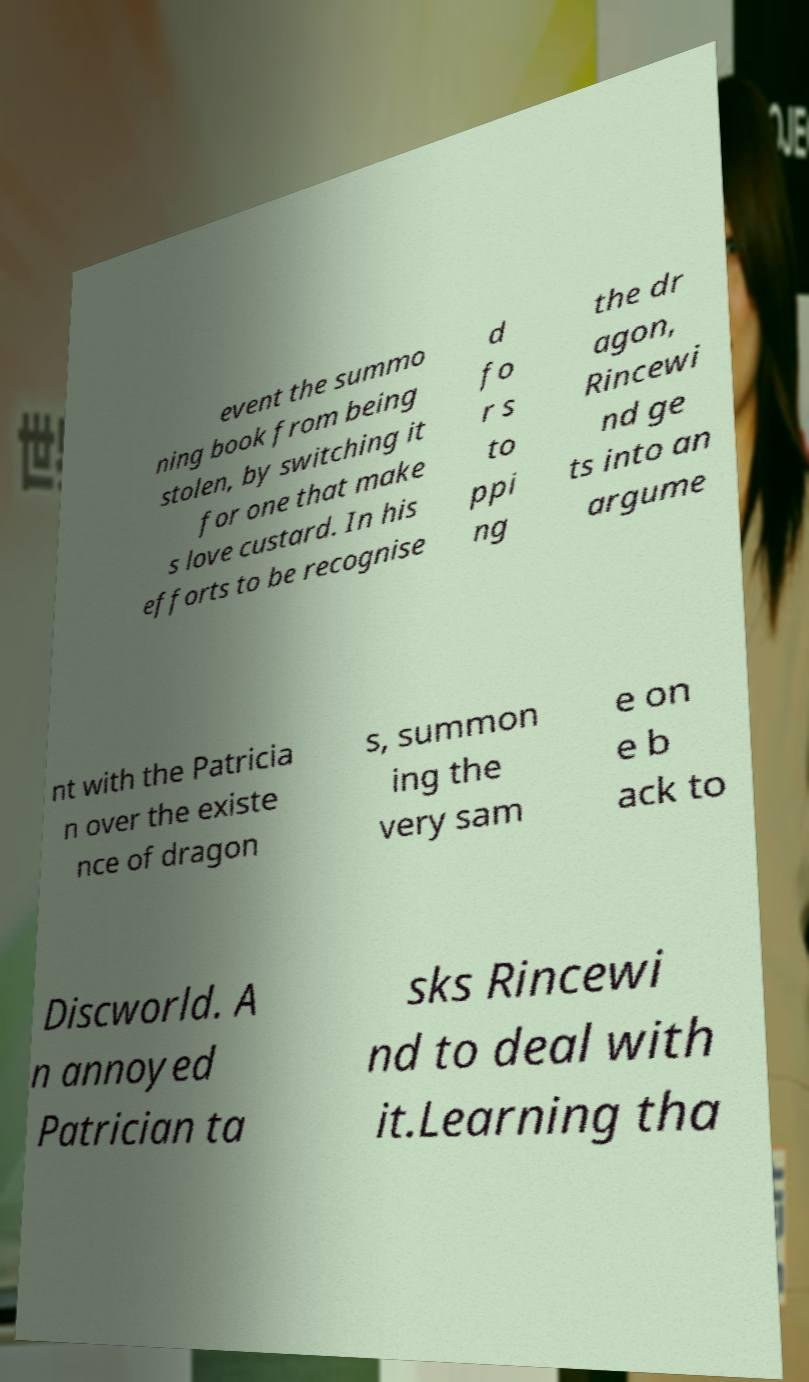Please read and relay the text visible in this image. What does it say? event the summo ning book from being stolen, by switching it for one that make s love custard. In his efforts to be recognise d fo r s to ppi ng the dr agon, Rincewi nd ge ts into an argume nt with the Patricia n over the existe nce of dragon s, summon ing the very sam e on e b ack to Discworld. A n annoyed Patrician ta sks Rincewi nd to deal with it.Learning tha 